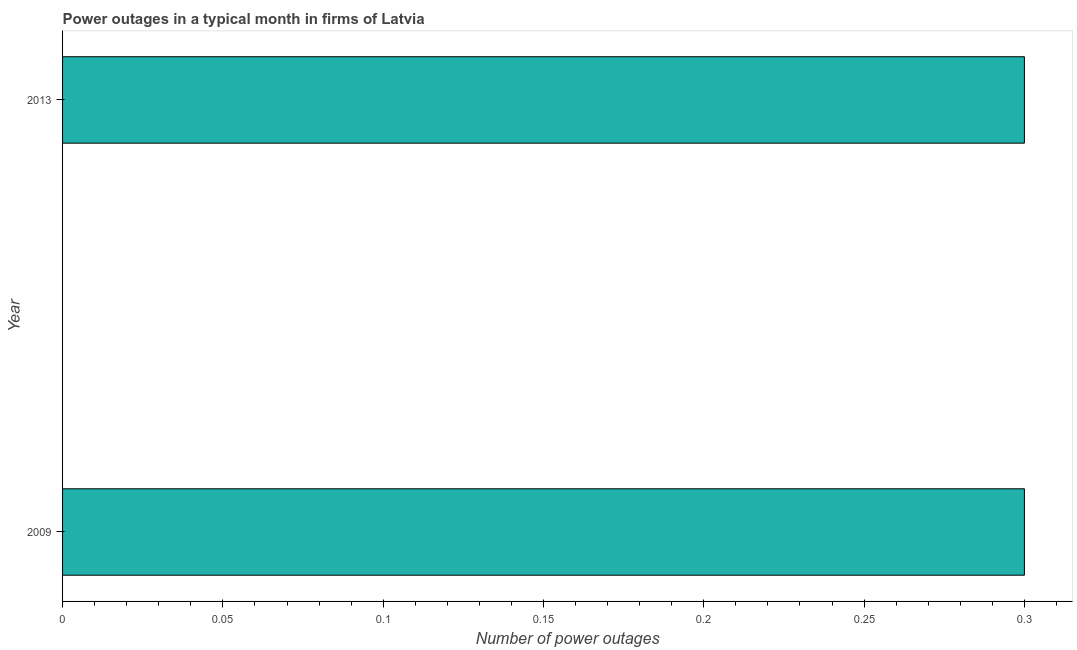Does the graph contain any zero values?
Offer a terse response. No. Does the graph contain grids?
Make the answer very short. No. What is the title of the graph?
Offer a very short reply. Power outages in a typical month in firms of Latvia. What is the label or title of the X-axis?
Keep it short and to the point. Number of power outages. What is the number of power outages in 2013?
Give a very brief answer. 0.3. Across all years, what is the maximum number of power outages?
Your response must be concise. 0.3. Across all years, what is the minimum number of power outages?
Provide a short and direct response. 0.3. In which year was the number of power outages maximum?
Your response must be concise. 2009. In how many years, is the number of power outages greater than 0.08 ?
Provide a short and direct response. 2. What is the ratio of the number of power outages in 2009 to that in 2013?
Make the answer very short. 1. In how many years, is the number of power outages greater than the average number of power outages taken over all years?
Your response must be concise. 0. How many bars are there?
Make the answer very short. 2. Are all the bars in the graph horizontal?
Your answer should be very brief. Yes. Are the values on the major ticks of X-axis written in scientific E-notation?
Your answer should be compact. No. 